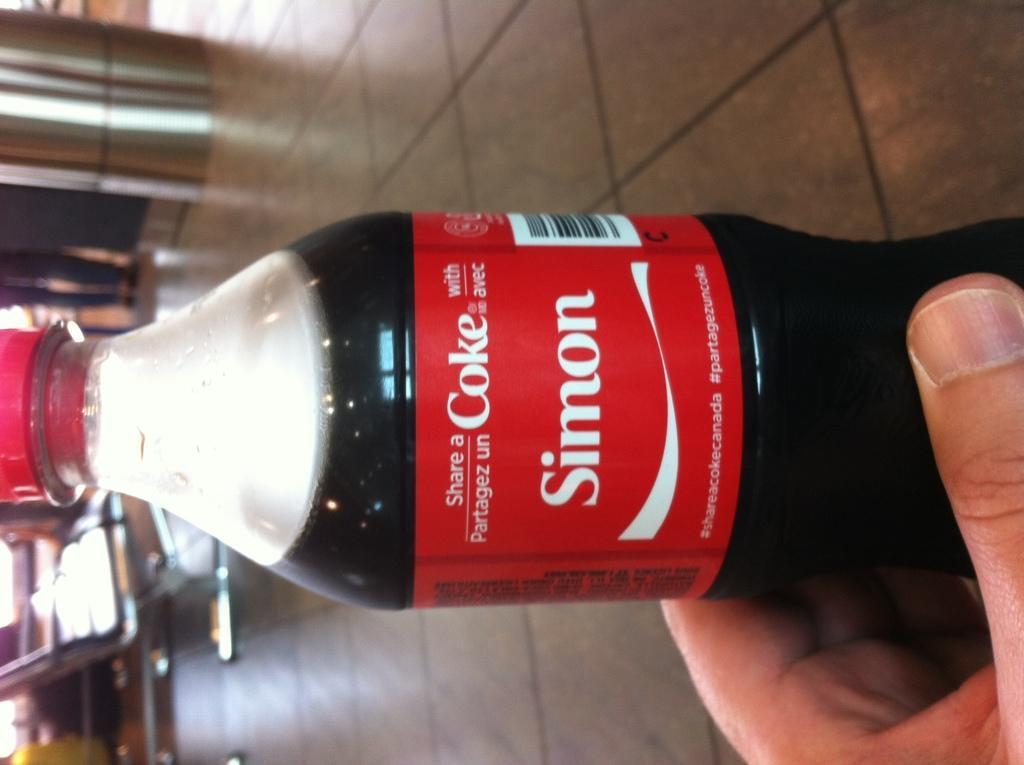Could you give a brief overview of what you see in this image? This image consist of cool drink bottle and hand of the person. In the background there are chairs,pillar, and legs of the person. 